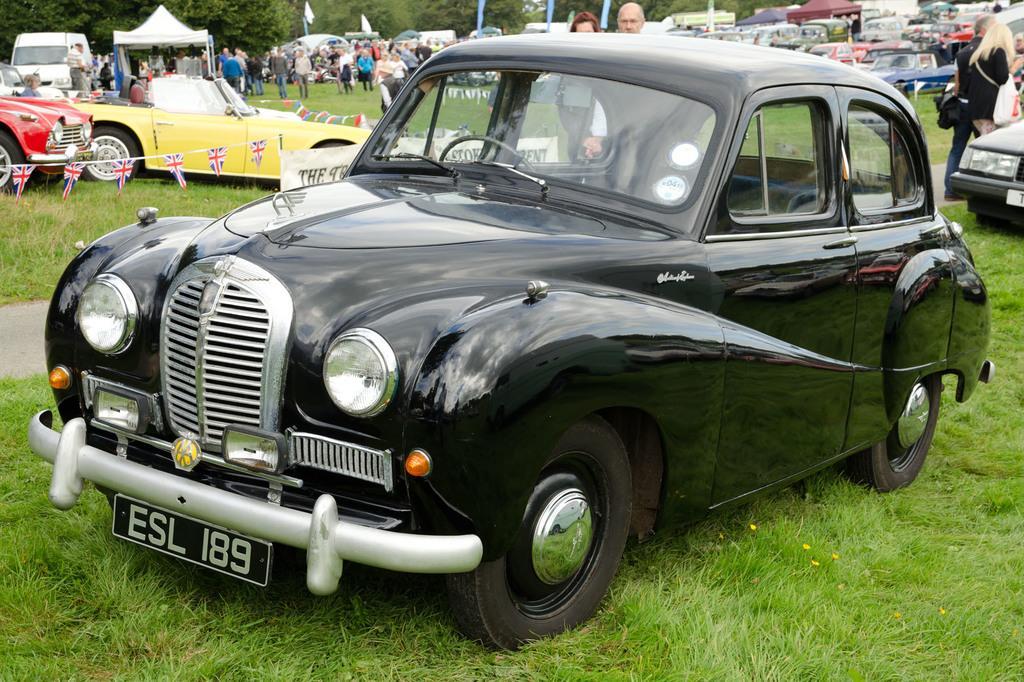How would you summarize this image in a sentence or two? In this image there are vehicles on the grass, group of people standing, stalls, decorative flags, and in the background there are trees. 